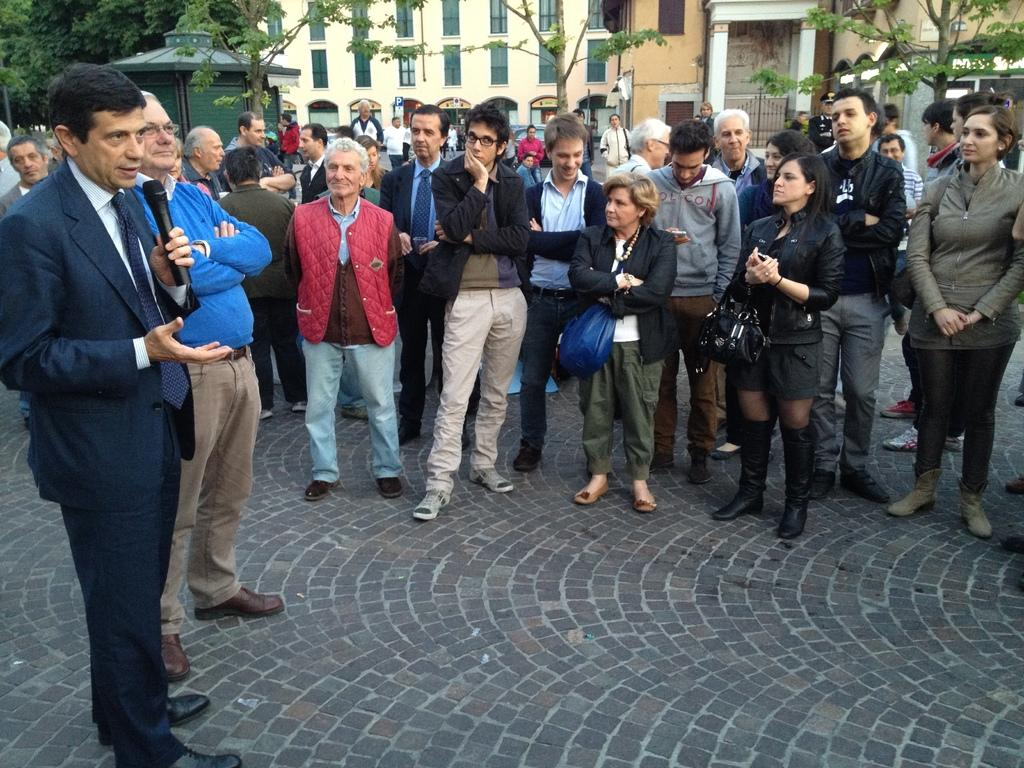What are the people in the image doing? The people in the image are standing on the road. What can be seen in the background of the image? There are buildings and trees in the background of the image. What type of pickle is being used to lock the door in the image? There is no pickle or door present in the image; it only features people standing on the road and buildings and trees in the background. 